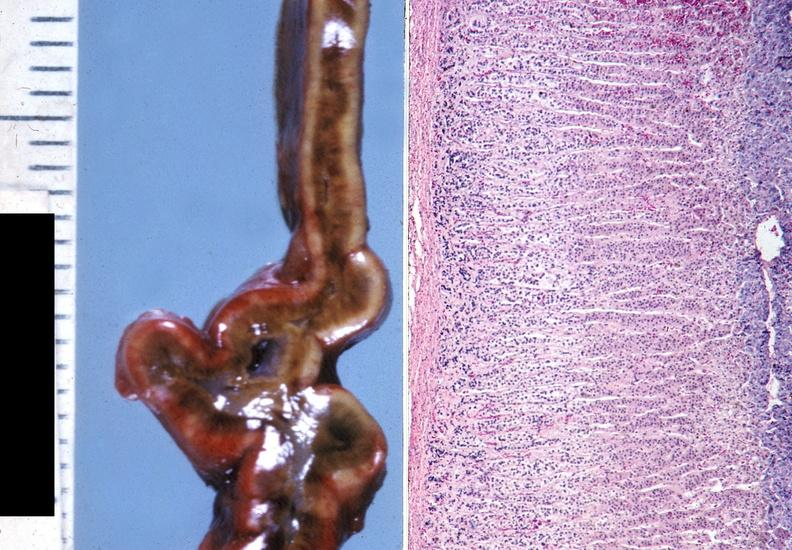what does this image show?
Answer the question using a single word or phrase. Adrenal 